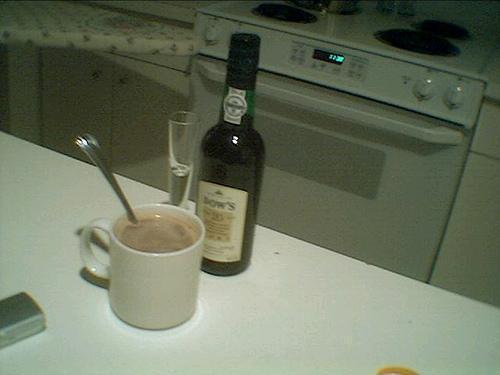How many glasses on counter?
Give a very brief answer. 1. 